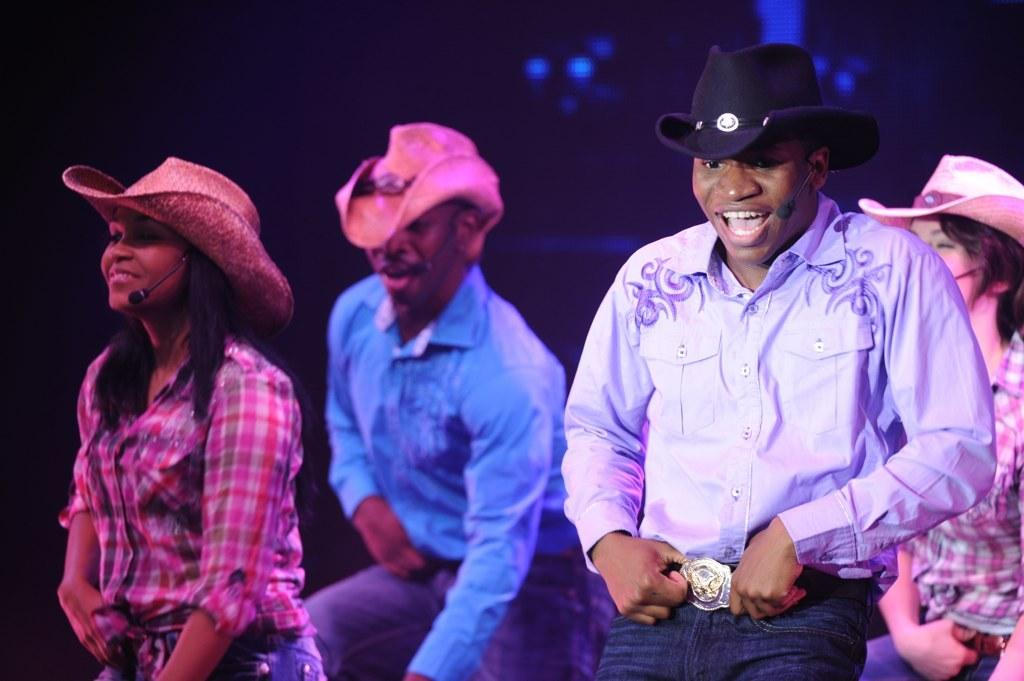How many people are in the image? There are four people in the image. What are the people doing in the image? The people appear to be dancing. Can you describe the background of the people? The background of the people is blurred. What are the people wearing on their heads? The people are wearing hats. What objects are around the heads of the people? There are microphones around the heads of the people. What type of teeth can be seen in the image? There are no teeth visible in the image; it features people dancing with hats and microphones. 